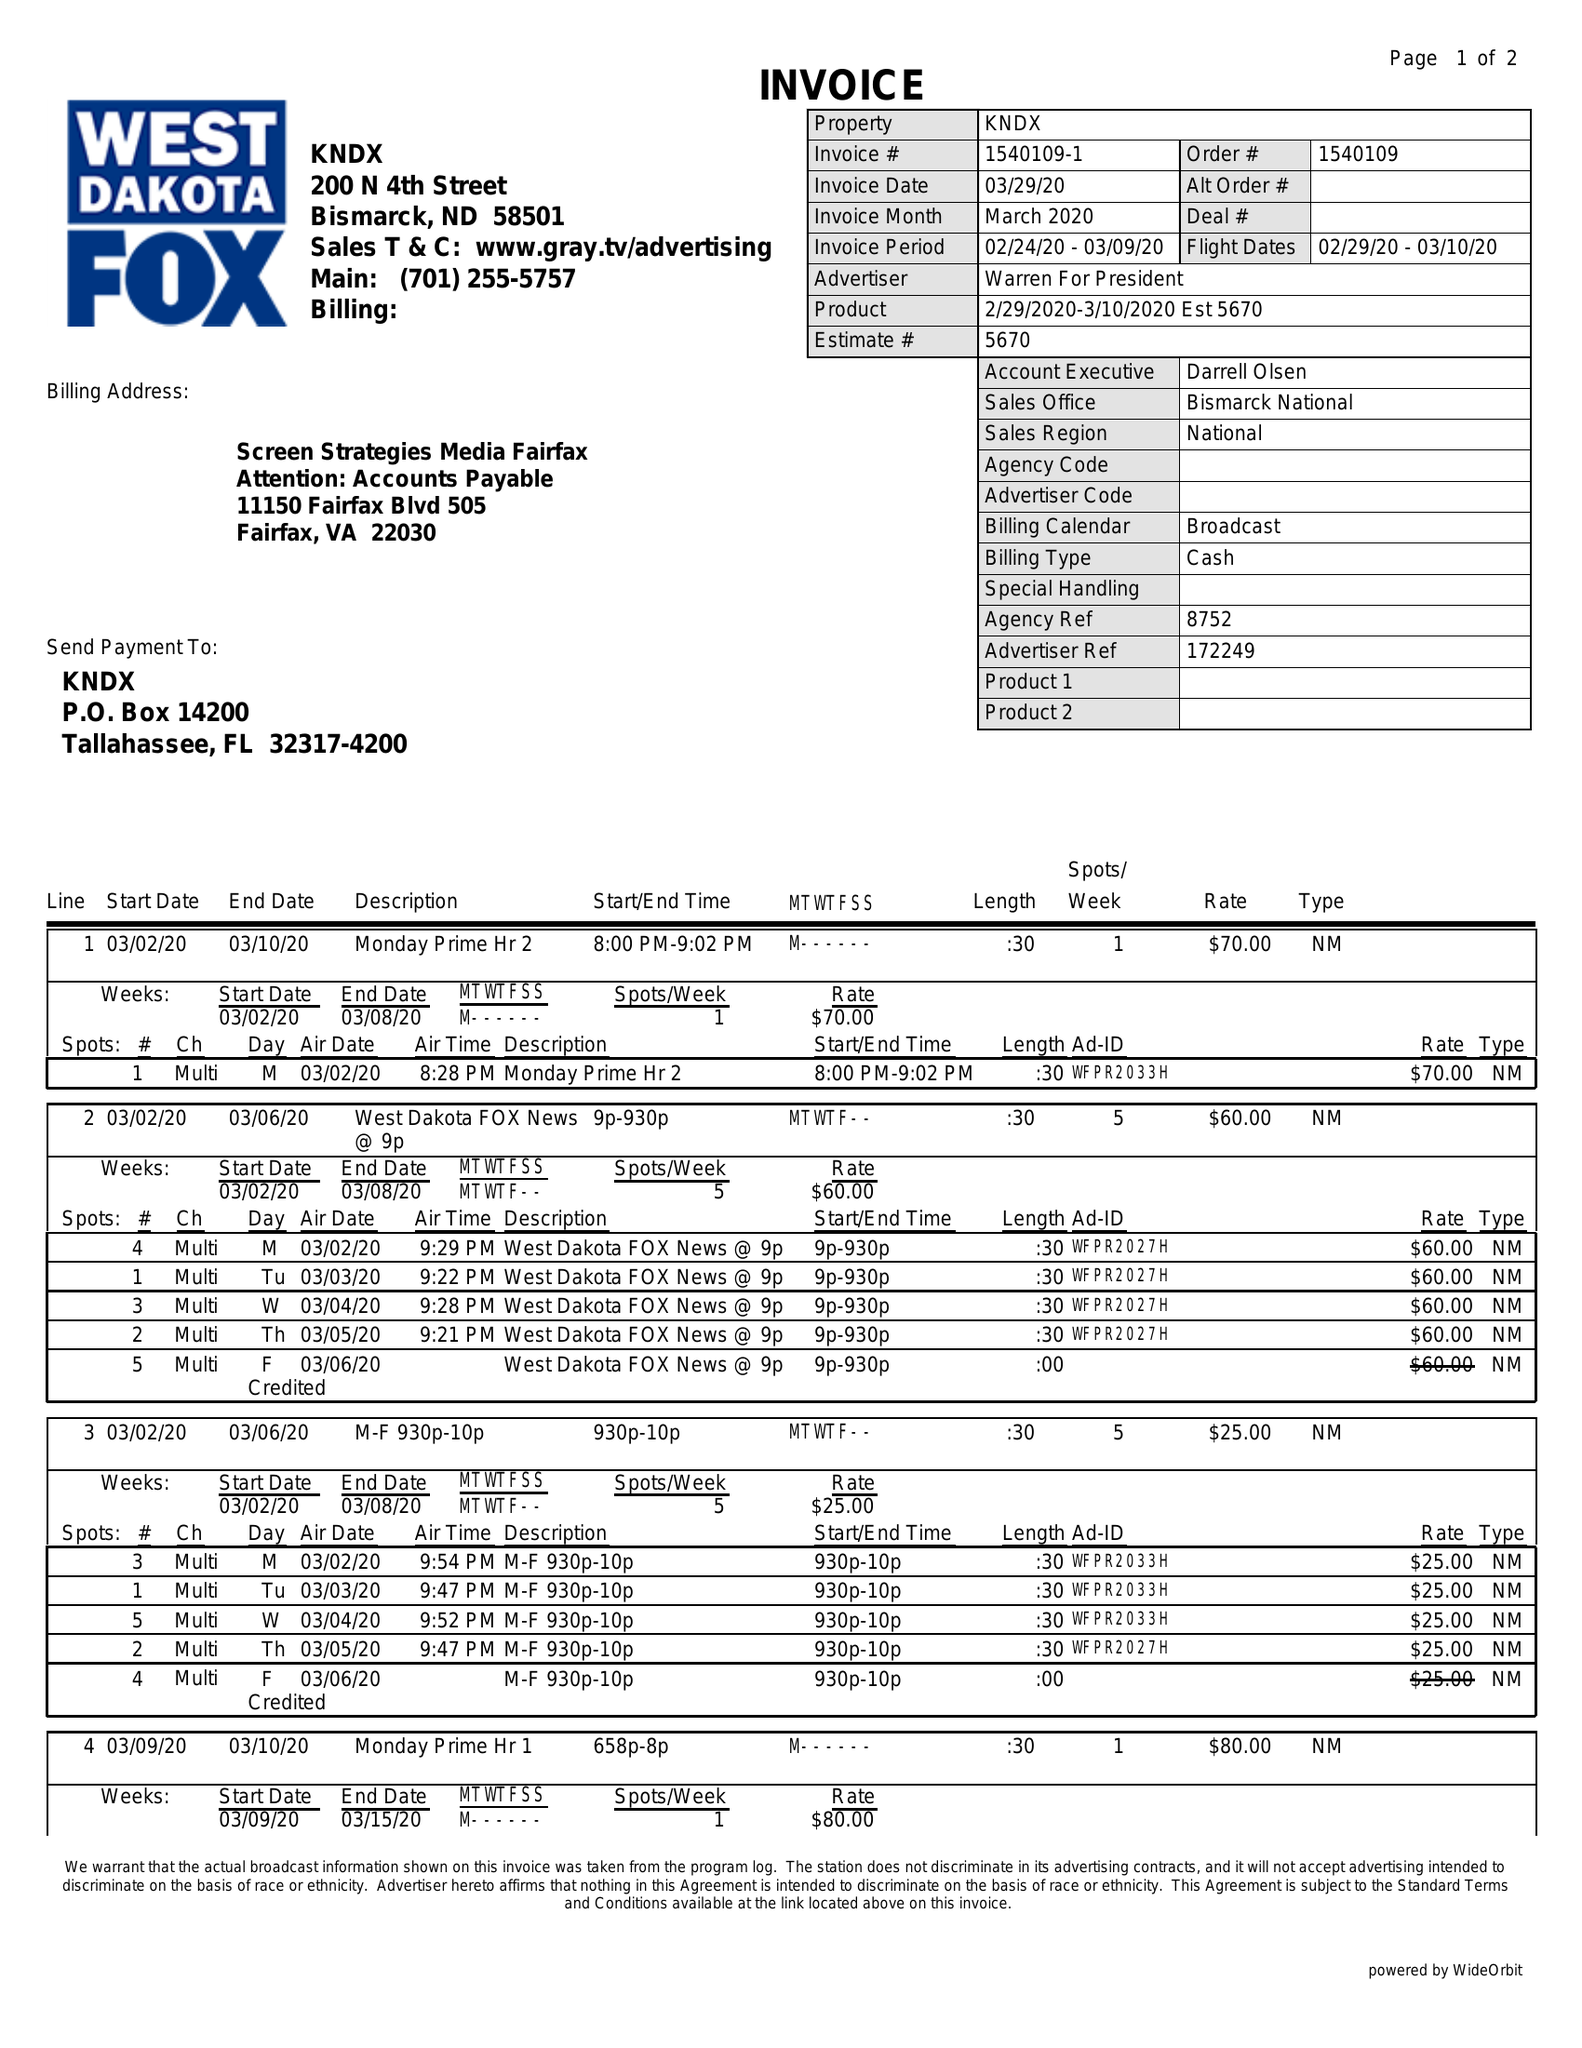What is the value for the advertiser?
Answer the question using a single word or phrase. WARREN FOR PRESIDENT 